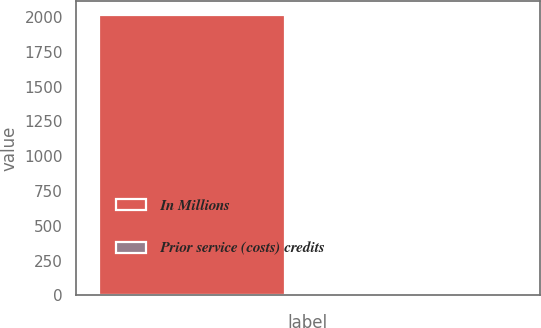Convert chart. <chart><loc_0><loc_0><loc_500><loc_500><bar_chart><fcel>In Millions<fcel>Prior service (costs) credits<nl><fcel>2016<fcel>6.8<nl></chart> 